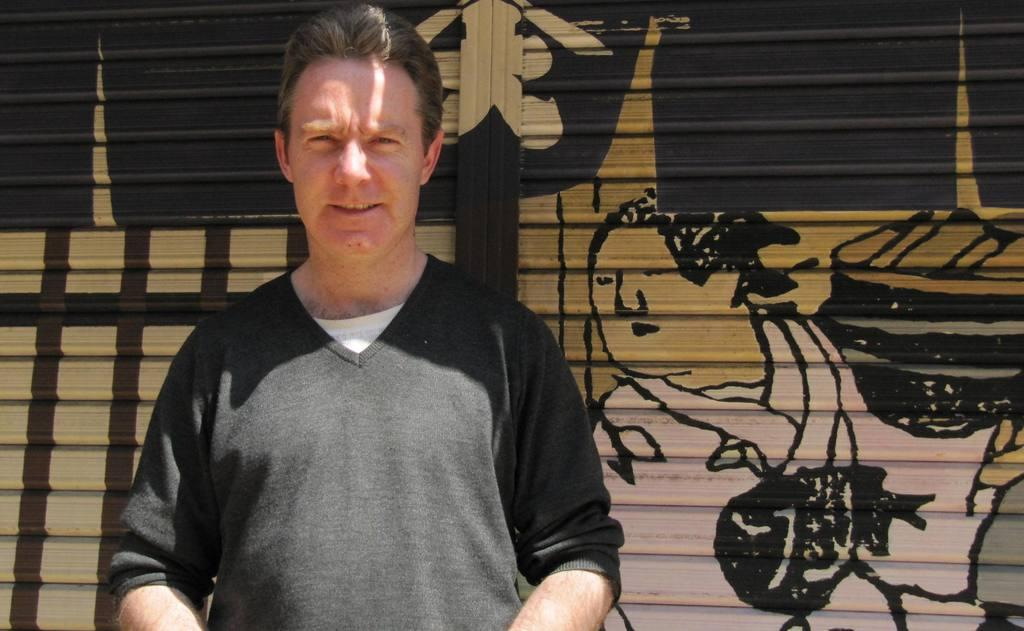What is the main subject of the image? There is a man standing in the image. Can you describe the background of the image? There are paintings on the shutters in the background of the image. Where is the edge of the bath located in the image? There is no bath present in the image, so it is not possible to determine the location of its edge. 